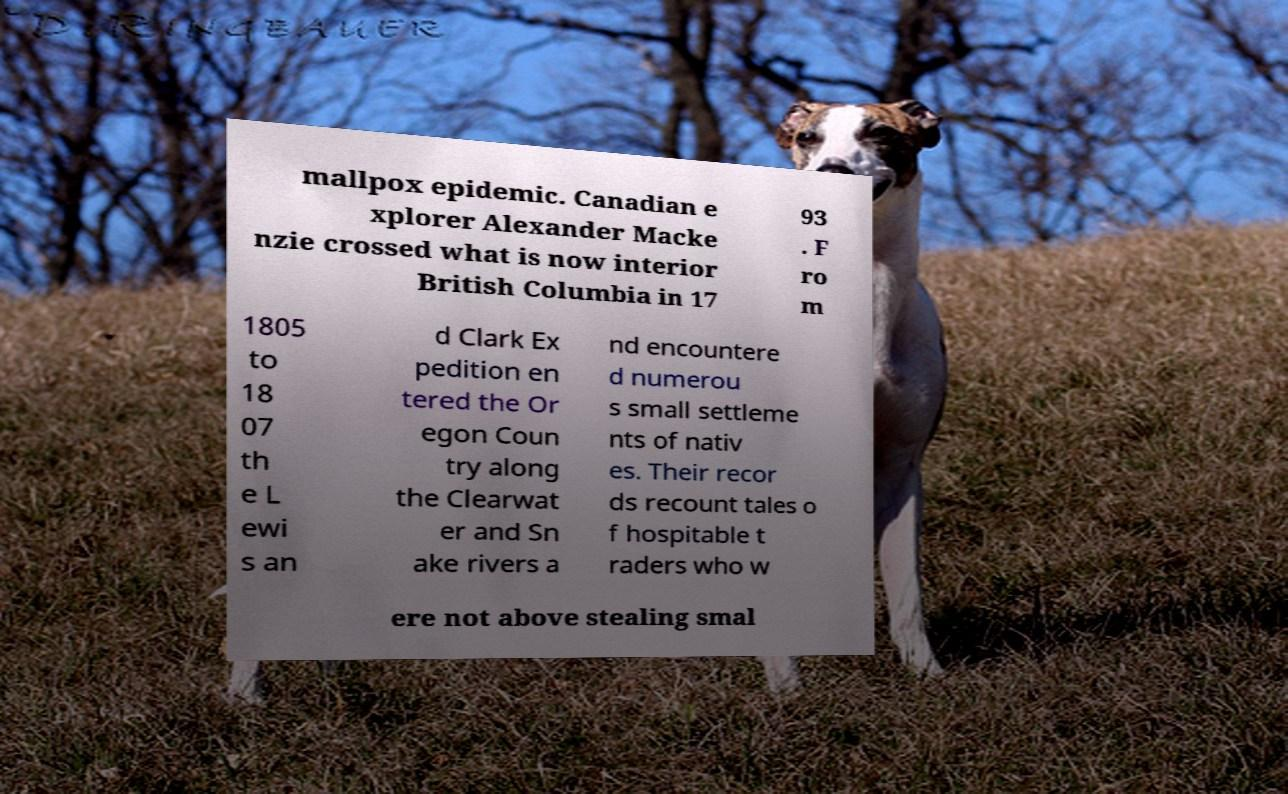Could you extract and type out the text from this image? mallpox epidemic. Canadian e xplorer Alexander Macke nzie crossed what is now interior British Columbia in 17 93 . F ro m 1805 to 18 07 th e L ewi s an d Clark Ex pedition en tered the Or egon Coun try along the Clearwat er and Sn ake rivers a nd encountere d numerou s small settleme nts of nativ es. Their recor ds recount tales o f hospitable t raders who w ere not above stealing smal 